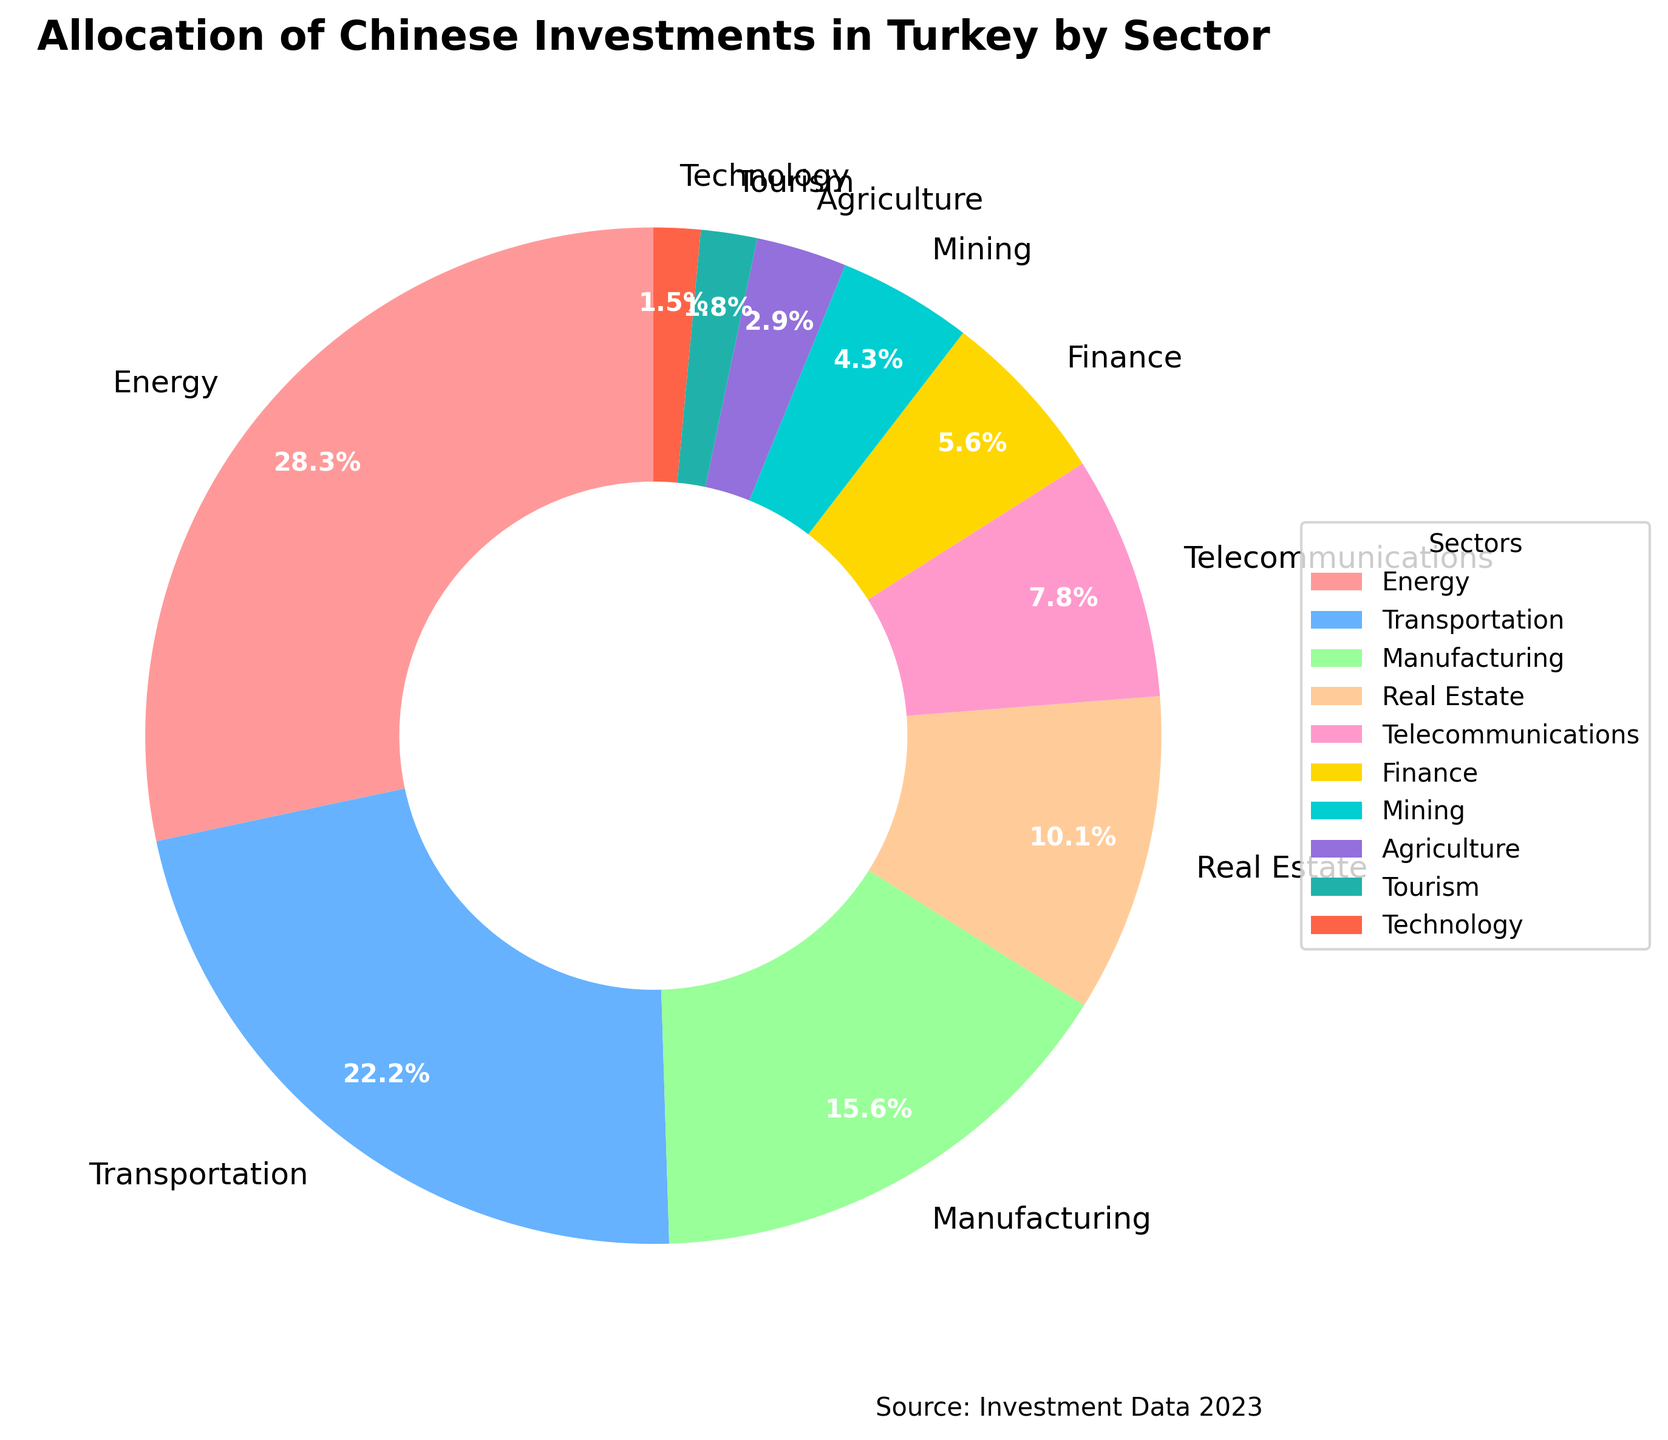Which sector receives the highest percentage of Chinese investments in Turkey? The figure shows a pie chart with different investment sectors, indicating the portion of investment each sector receives. The largest wedge corresponds to the Energy sector.
Answer: Energy Which sector receives the second highest percentage of Chinese investments? Identifying the second largest wedge in the pie chart reveals it is the Transportation sector.
Answer: Transportation What is the combined percentage of Chinese investments in Telecommunications and Technology? According to the data provided, Telecommunications has 7.8% and Technology has 1.5%. Summing these values gives 7.8% + 1.5% = 9.3%.
Answer: 9.3% How much more investment does the Manufacturing sector receive compared to the Mining sector? The Manufacturing sector has 15.7%, and the Mining sector has 4.3%. Subtracting the Mining investment from Manufacturing gives 15.7% - 4.3% = 11.4%.
Answer: 11.4% Which sectors receive less than 5% of Chinese investments? Examining the sectors with the smallest wedges in the pie chart shows that Mining, Agriculture, Tourism, and Technology receive less than 5%.
Answer: Mining, Agriculture, Tourism, Technology What is the total percentage of Chinese investments in the Energy, Transportation, and Manufacturing sectors combined? Summing the percentages of these three sectors: Energy (28.5%), Transportation (22.3%), and Manufacturing (15.7%) results in 28.5% + 22.3% + 15.7% = 66.5%.
Answer: 66.5% Which sector receives nearly double the investment of Finance? Finance receives 5.6% investment. The closest sector with nearly double this value is Real Estate at 10.2%.
Answer: Real Estate What percentage of Chinese investments goes into sectors outside the top three sectors? First, determine the top three sectors: Energy (28.5%), Transportation (22.3%), and Manufacturing (15.7%), summing to 28.5% + 22.3% + 15.7% = 66.5%. Subtracting this from 100% gives 100% - 66.5% = 33.5%.
Answer: 33.5% Are there more funds allocated to Telecommunications or to Real Estate? The wedge sizes indicate that Real Estate with 10.2% receives more funds than Telecommunications with 7.8%.
Answer: Real Estate Which sector receives the least amount of Chinese investments? The pie chart shows that the smallest wedge belongs to the Technology sector, receiving 1.5% of the investments.
Answer: Technology 